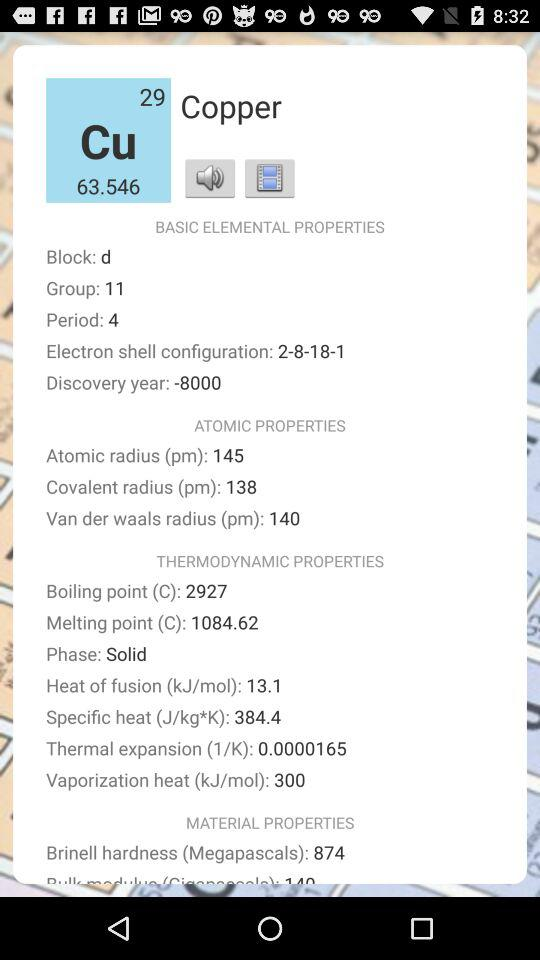What is the atomic number of copper? The atomic number of copper is 29. 